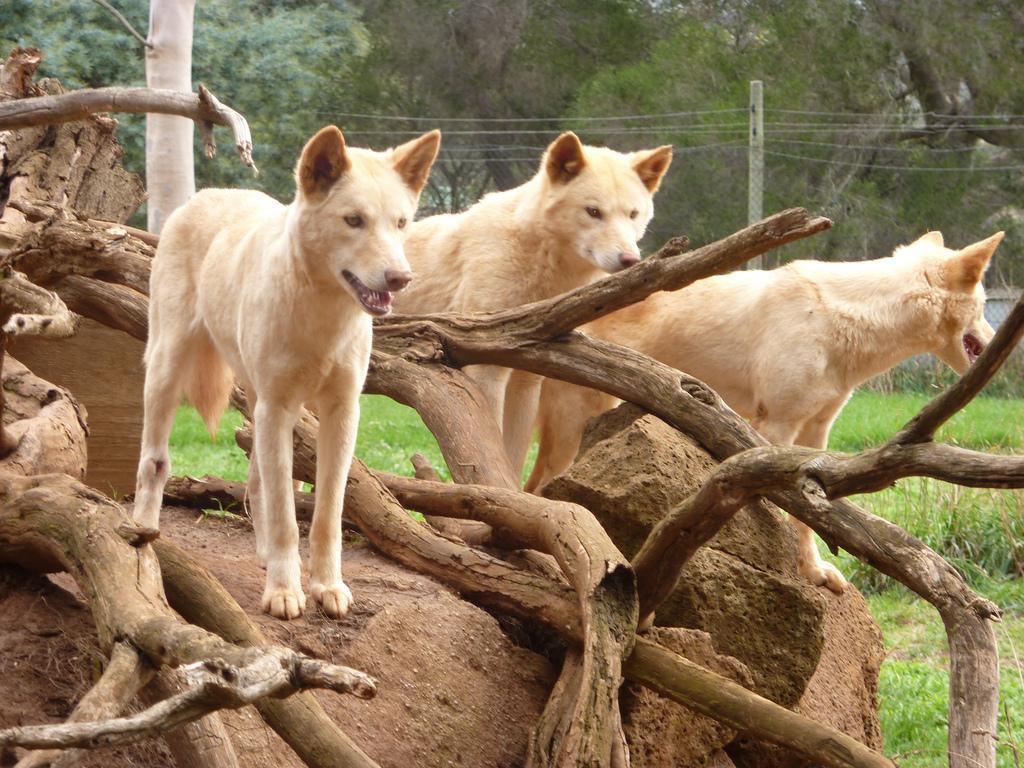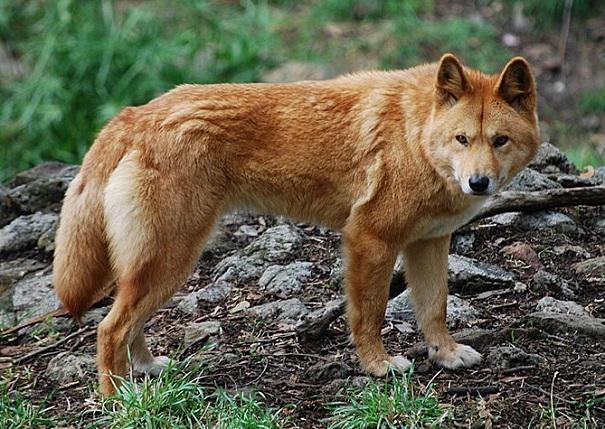The first image is the image on the left, the second image is the image on the right. Given the left and right images, does the statement "There are exactly four coyotes." hold true? Answer yes or no. Yes. 